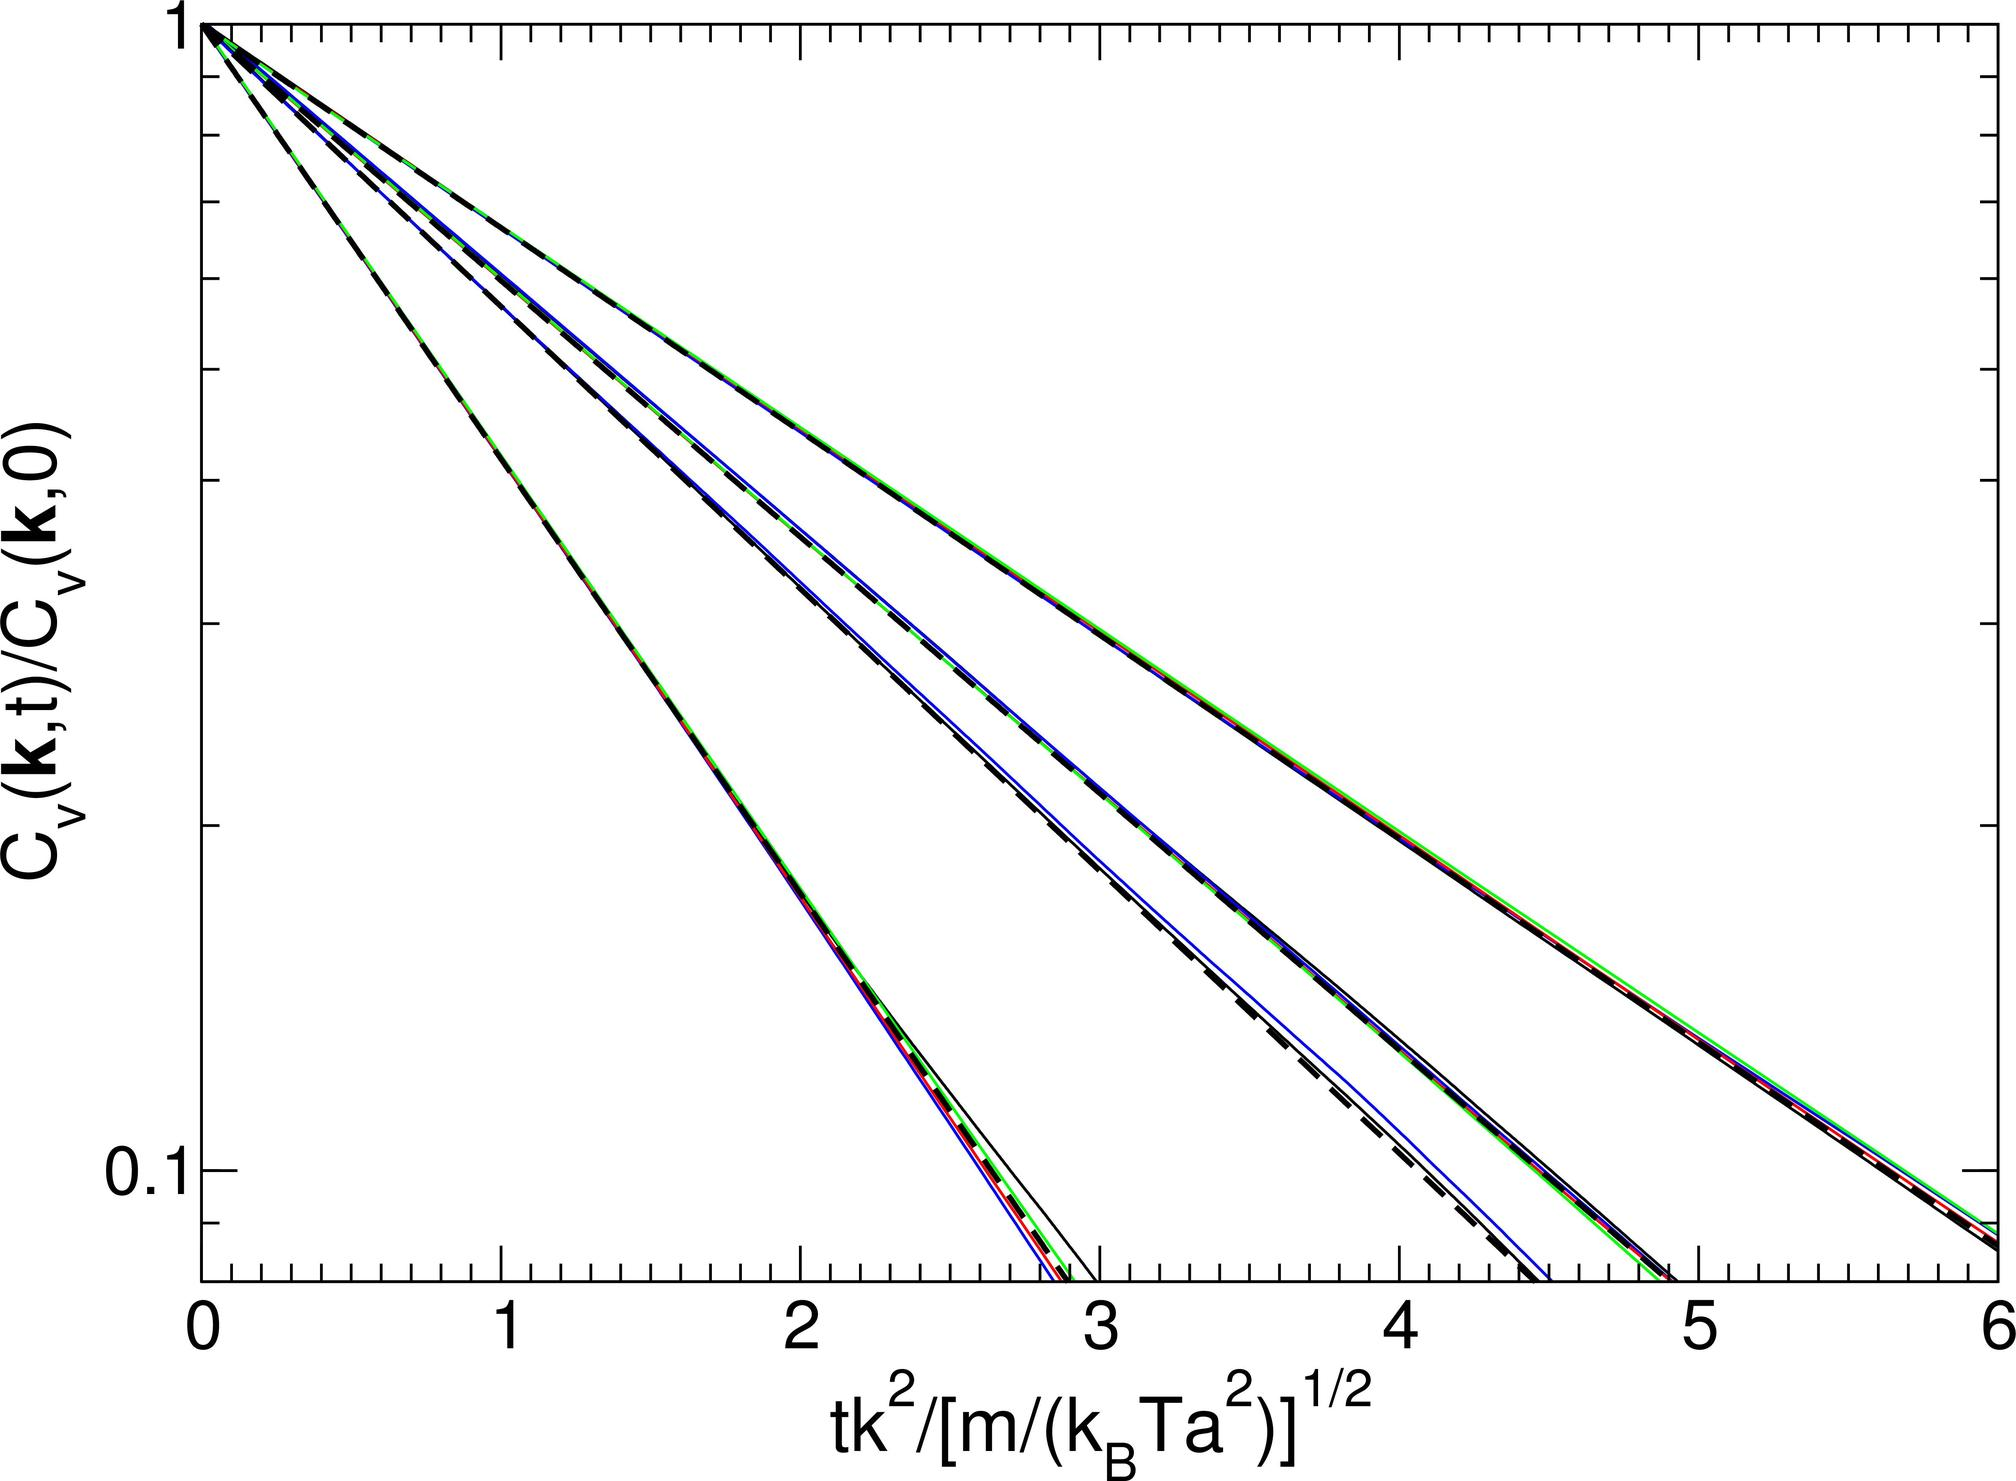How might changes in \( K \) while keeping other parameters constant impact the graph? Modifying the parameter \( K \), while holding others constant, would affect the steepness and position of the curves. An increase in \( K \) would cause the curves to become steeper and shift slightly to the right, as the value of \( tK^2 \) in the numerator of the x-axis expression would increase, requiring a higher contribution to achieve equivalent x-axis values. Conversely, decreasing \( K \) makes the curves less steep and shifts them to the left. 